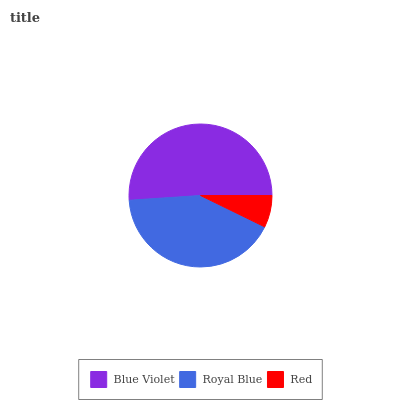Is Red the minimum?
Answer yes or no. Yes. Is Blue Violet the maximum?
Answer yes or no. Yes. Is Royal Blue the minimum?
Answer yes or no. No. Is Royal Blue the maximum?
Answer yes or no. No. Is Blue Violet greater than Royal Blue?
Answer yes or no. Yes. Is Royal Blue less than Blue Violet?
Answer yes or no. Yes. Is Royal Blue greater than Blue Violet?
Answer yes or no. No. Is Blue Violet less than Royal Blue?
Answer yes or no. No. Is Royal Blue the high median?
Answer yes or no. Yes. Is Royal Blue the low median?
Answer yes or no. Yes. Is Red the high median?
Answer yes or no. No. Is Blue Violet the low median?
Answer yes or no. No. 